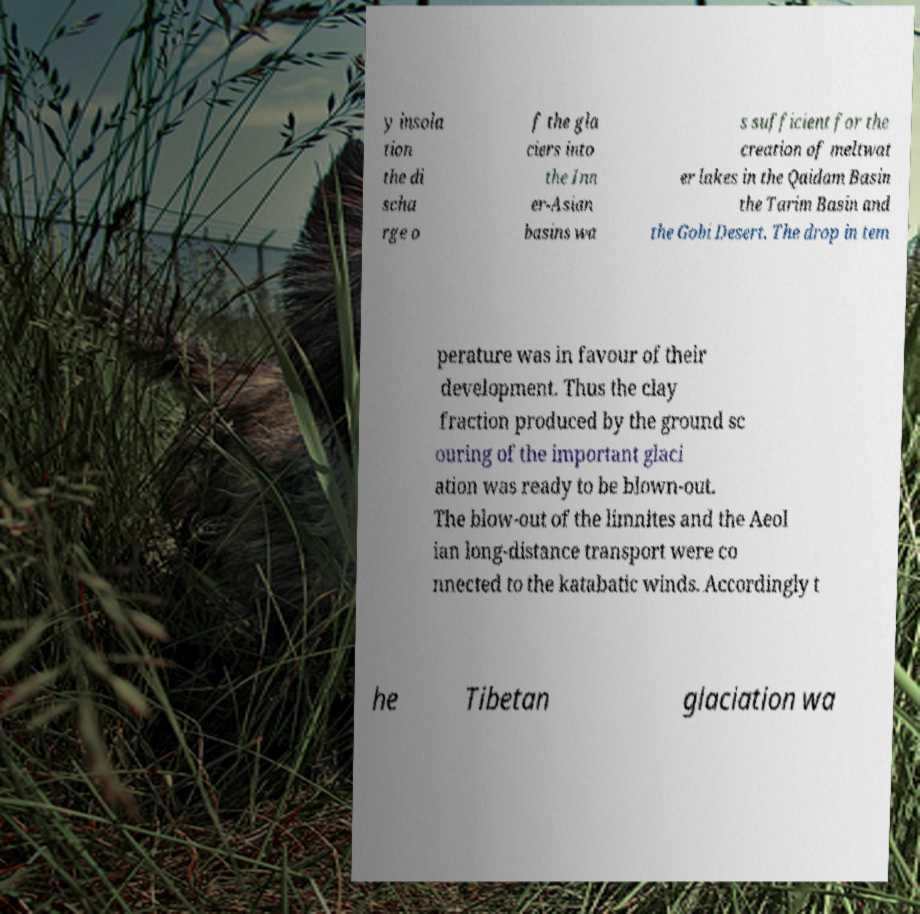Please read and relay the text visible in this image. What does it say? y insola tion the di scha rge o f the gla ciers into the Inn er-Asian basins wa s sufficient for the creation of meltwat er lakes in the Qaidam Basin the Tarim Basin and the Gobi Desert. The drop in tem perature was in favour of their development. Thus the clay fraction produced by the ground sc ouring of the important glaci ation was ready to be blown-out. The blow-out of the limnites and the Aeol ian long-distance transport were co nnected to the katabatic winds. Accordingly t he Tibetan glaciation wa 